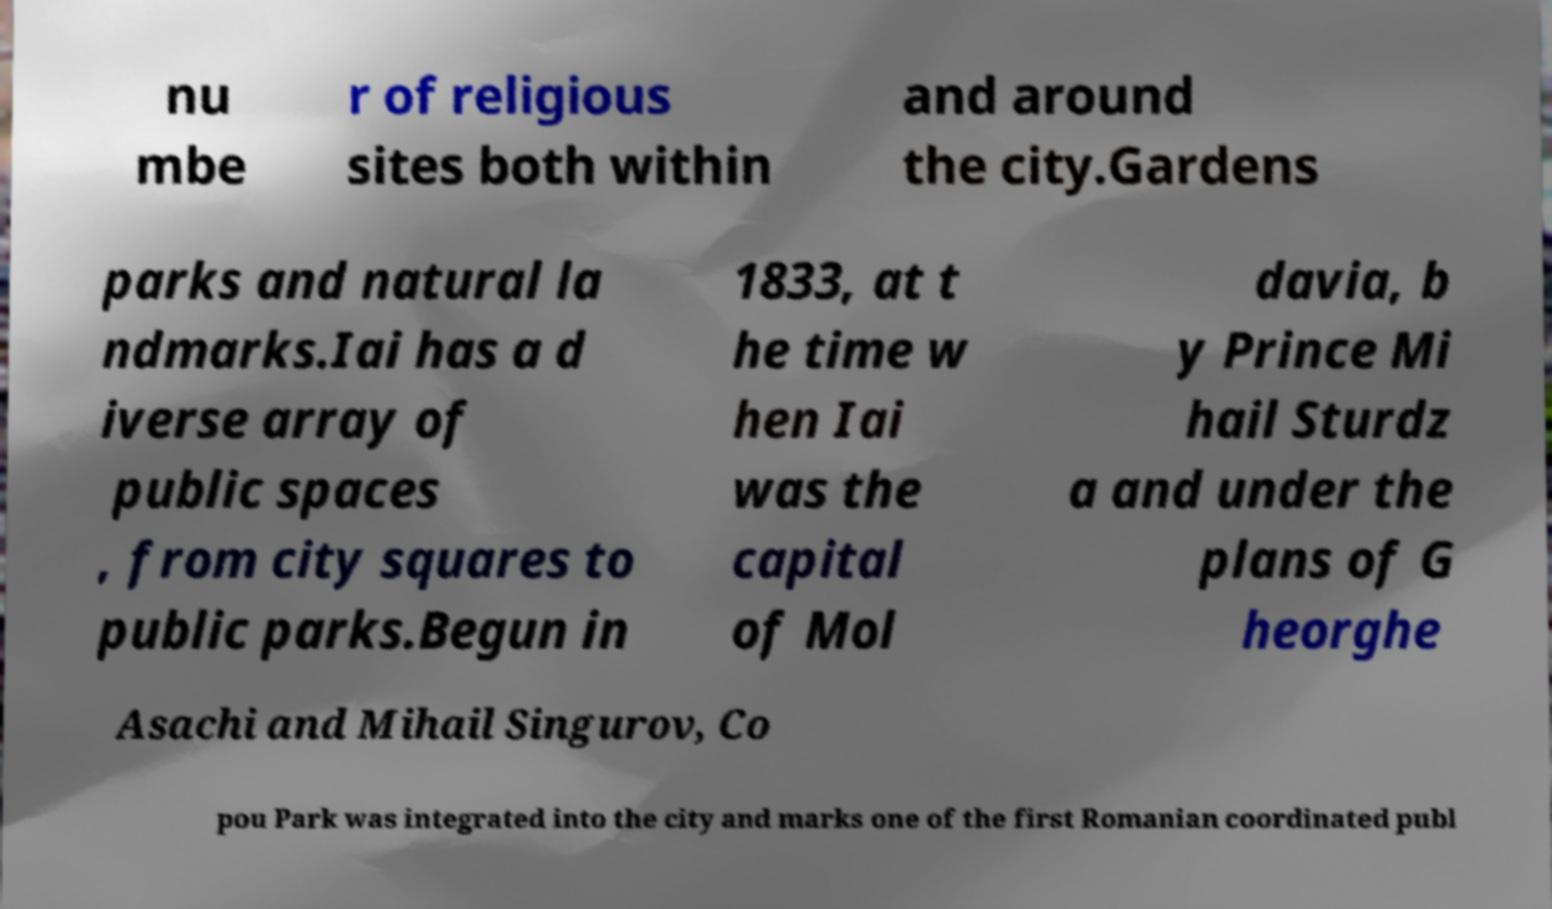For documentation purposes, I need the text within this image transcribed. Could you provide that? nu mbe r of religious sites both within and around the city.Gardens parks and natural la ndmarks.Iai has a d iverse array of public spaces , from city squares to public parks.Begun in 1833, at t he time w hen Iai was the capital of Mol davia, b y Prince Mi hail Sturdz a and under the plans of G heorghe Asachi and Mihail Singurov, Co pou Park was integrated into the city and marks one of the first Romanian coordinated publ 